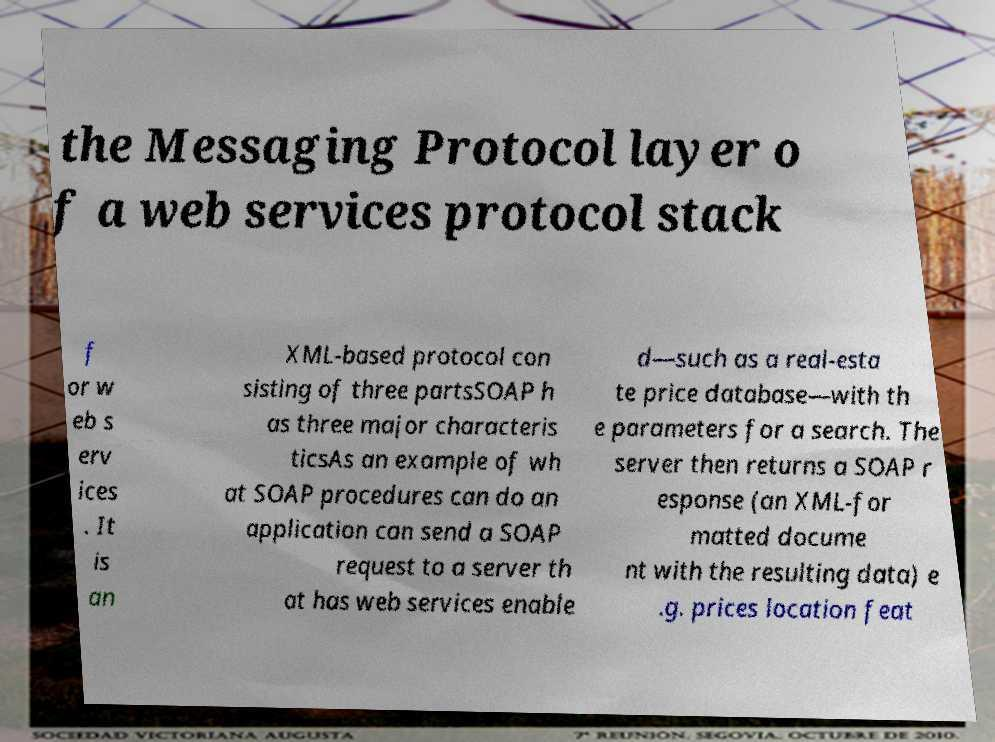Can you accurately transcribe the text from the provided image for me? the Messaging Protocol layer o f a web services protocol stack f or w eb s erv ices . It is an XML-based protocol con sisting of three partsSOAP h as three major characteris ticsAs an example of wh at SOAP procedures can do an application can send a SOAP request to a server th at has web services enable d—such as a real-esta te price database—with th e parameters for a search. The server then returns a SOAP r esponse (an XML-for matted docume nt with the resulting data) e .g. prices location feat 